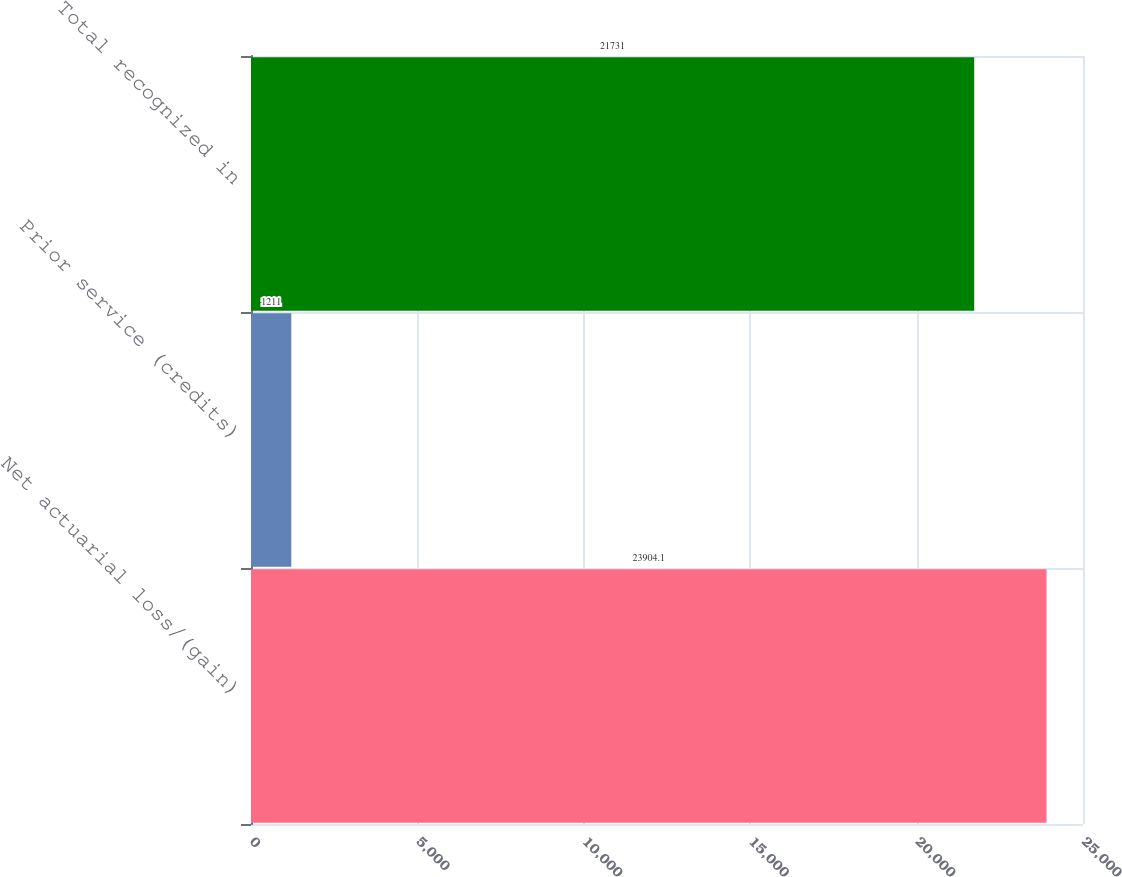<chart> <loc_0><loc_0><loc_500><loc_500><bar_chart><fcel>Net actuarial loss/(gain)<fcel>Prior service (credits)<fcel>Total recognized in<nl><fcel>23904.1<fcel>1211<fcel>21731<nl></chart> 